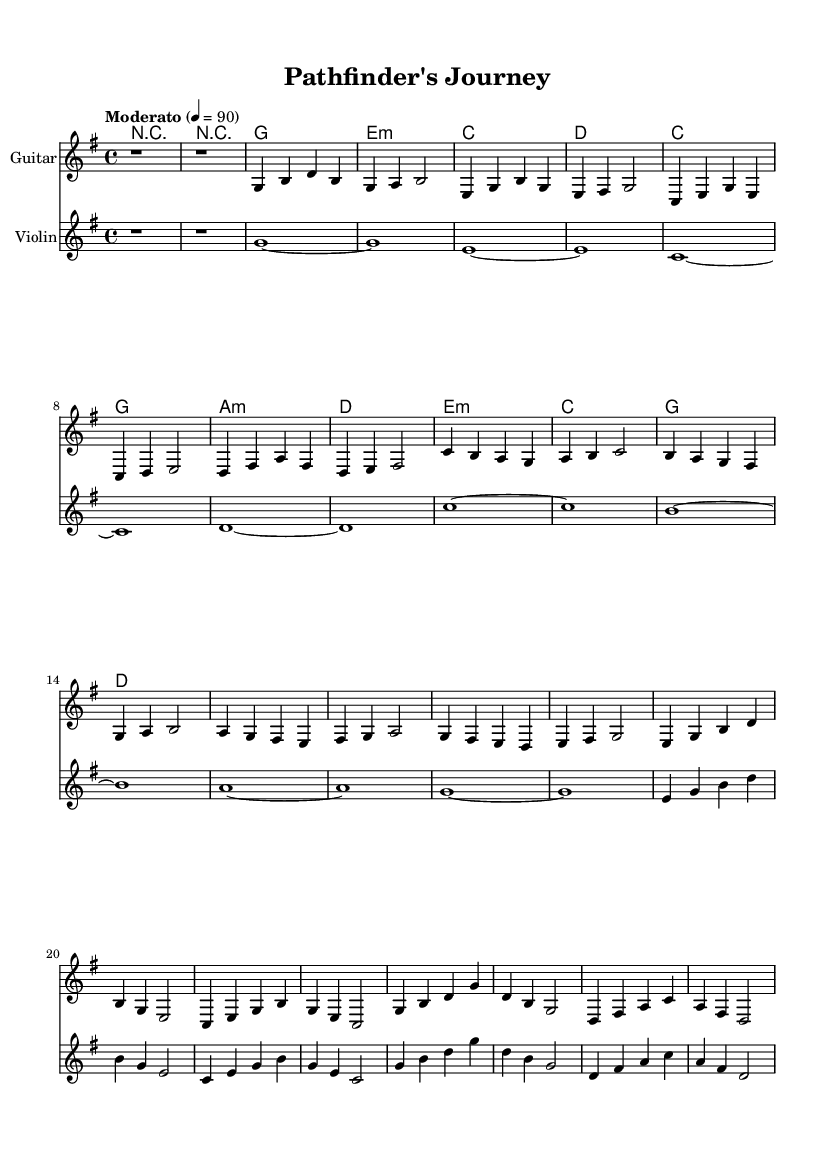What is the key signature of this music? The key signature of this music is G major, which has one sharp (F#).
Answer: G major What is the time signature of the piece? The time signature indicated in the music is 4/4, meaning there are four beats per measure.
Answer: 4/4 What is the tempo marking of this piece? The tempo marking indicates "Moderato" at a quarter note equals 90 beats per minute.
Answer: Moderato How many main sections does this piece have? The piece consists of an Intro, Verse 1, Chorus, and Bridge, making a total of four main sections.
Answer: Four What chord is used in the first measure of the guitar part? The first measure of the guitar part has a rest indicating that no chords are played, showing silence.
Answer: Rest In the Chorus, what is the last chord played? The last chord in the Chorus is D major, as shown in the chord progression for that section.
Answer: D major What instrument plays the first melodic line? The first melodic line is played by the guitar, as indicated by the staff label and notation.
Answer: Guitar 